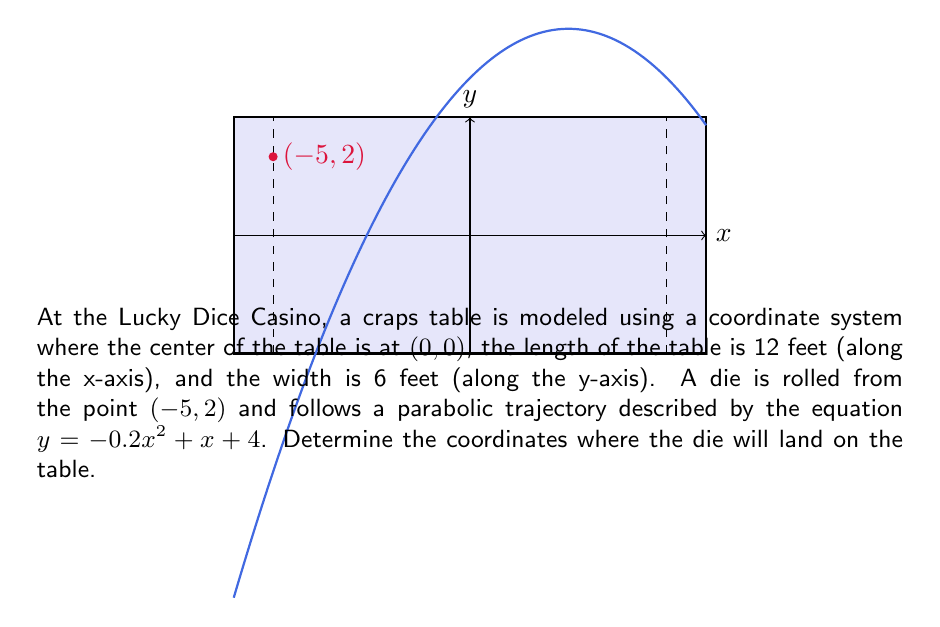Give your solution to this math problem. Let's approach this step-by-step:

1) The die's trajectory is given by the equation $y = -0.2x^2 + x + 4$.

2) To find where the die lands, we need to find the intersection of this parabola with the table surface. The table extends from x = -6 to x = 6 (12 feet long, centered at 0).

3) We can find the y-coordinates at these x-values:

   At x = -6: $y = -0.2(-6)^2 + (-6) + 4 = -7.2 - 6 + 4 = -9.2$
   At x = 6: $y = -0.2(6)^2 + 6 + 4 = -7.2 + 6 + 4 = 2.8$

4) The y-coordinate at x = -6 is below the table, while at x = 6 it's above. This means the die lands somewhere between these two x-values.

5) To find the exact landing point, we need to solve the equation:

   $-0.2x^2 + x + 4 = -3$ (since the bottom edge of the table is at y = -3)

6) Rearranging the equation:
   $-0.2x^2 + x + 7 = 0$

7) This is a quadratic equation. We can solve it using the quadratic formula:
   $x = \frac{-b \pm \sqrt{b^2 - 4ac}}{2a}$

   where $a = -0.2$, $b = 1$, and $c = 7$

8) Plugging in these values:
   $x = \frac{-1 \pm \sqrt{1^2 - 4(-0.2)(7)}}{2(-0.2)}$
   $= \frac{-1 \pm \sqrt{1 + 5.6}}{-0.4}$
   $= \frac{-1 \pm \sqrt{6.6}}{-0.4}$
   $= \frac{-1 \pm 2.57}{-0.4}$

9) This gives us two solutions:
   $x_1 = \frac{-1 + 2.57}{-0.4} = -3.925$
   $x_2 = \frac{-1 - 2.57}{-0.4} = 8.925$

10) The second solution is outside the table, so the die lands at x = -3.925.

11) We can find the corresponding y-coordinate by plugging this x-value back into the original equation:
    $y = -0.2(-3.925)^2 + (-3.925) + 4 = -3$

Therefore, the die lands at the point (-3.925, -3).
Answer: (-3.925, -3) 